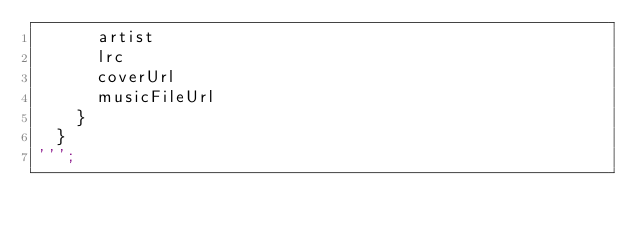Convert code to text. <code><loc_0><loc_0><loc_500><loc_500><_Dart_>      artist
      lrc
      coverUrl
      musicFileUrl
    }
  }
''';
</code> 